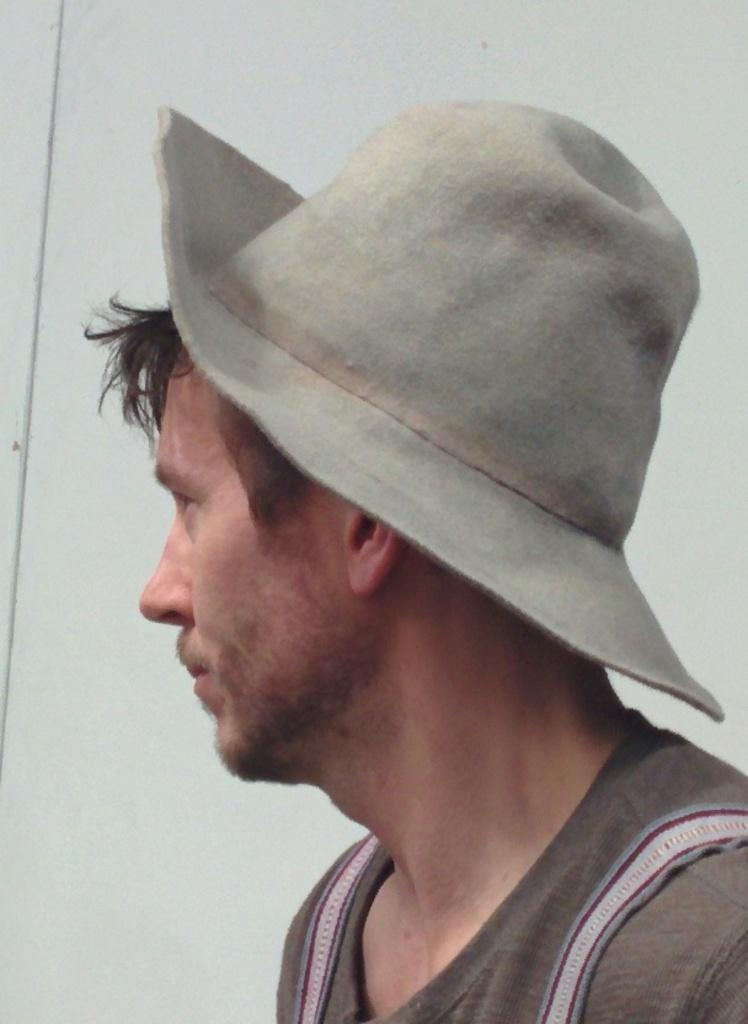Who is the main subject in the image? There is a man in the image. Where is the man located in relation to the image? The man is in the foreground. What is the man wearing on his head? The man is wearing a hat. What type of window can be seen in the background of the image? There is no window present in the image; it only features a man in the foreground. 